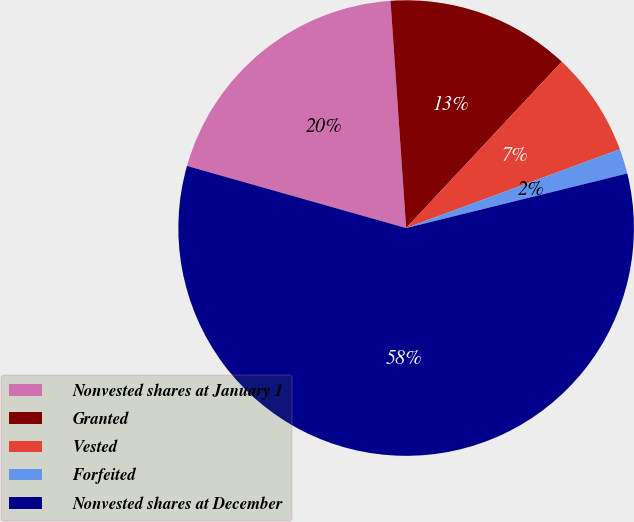Convert chart. <chart><loc_0><loc_0><loc_500><loc_500><pie_chart><fcel>Nonvested shares at January 1<fcel>Granted<fcel>Vested<fcel>Forfeited<fcel>Nonvested shares at December<nl><fcel>19.51%<fcel>13.06%<fcel>7.41%<fcel>1.77%<fcel>58.25%<nl></chart> 